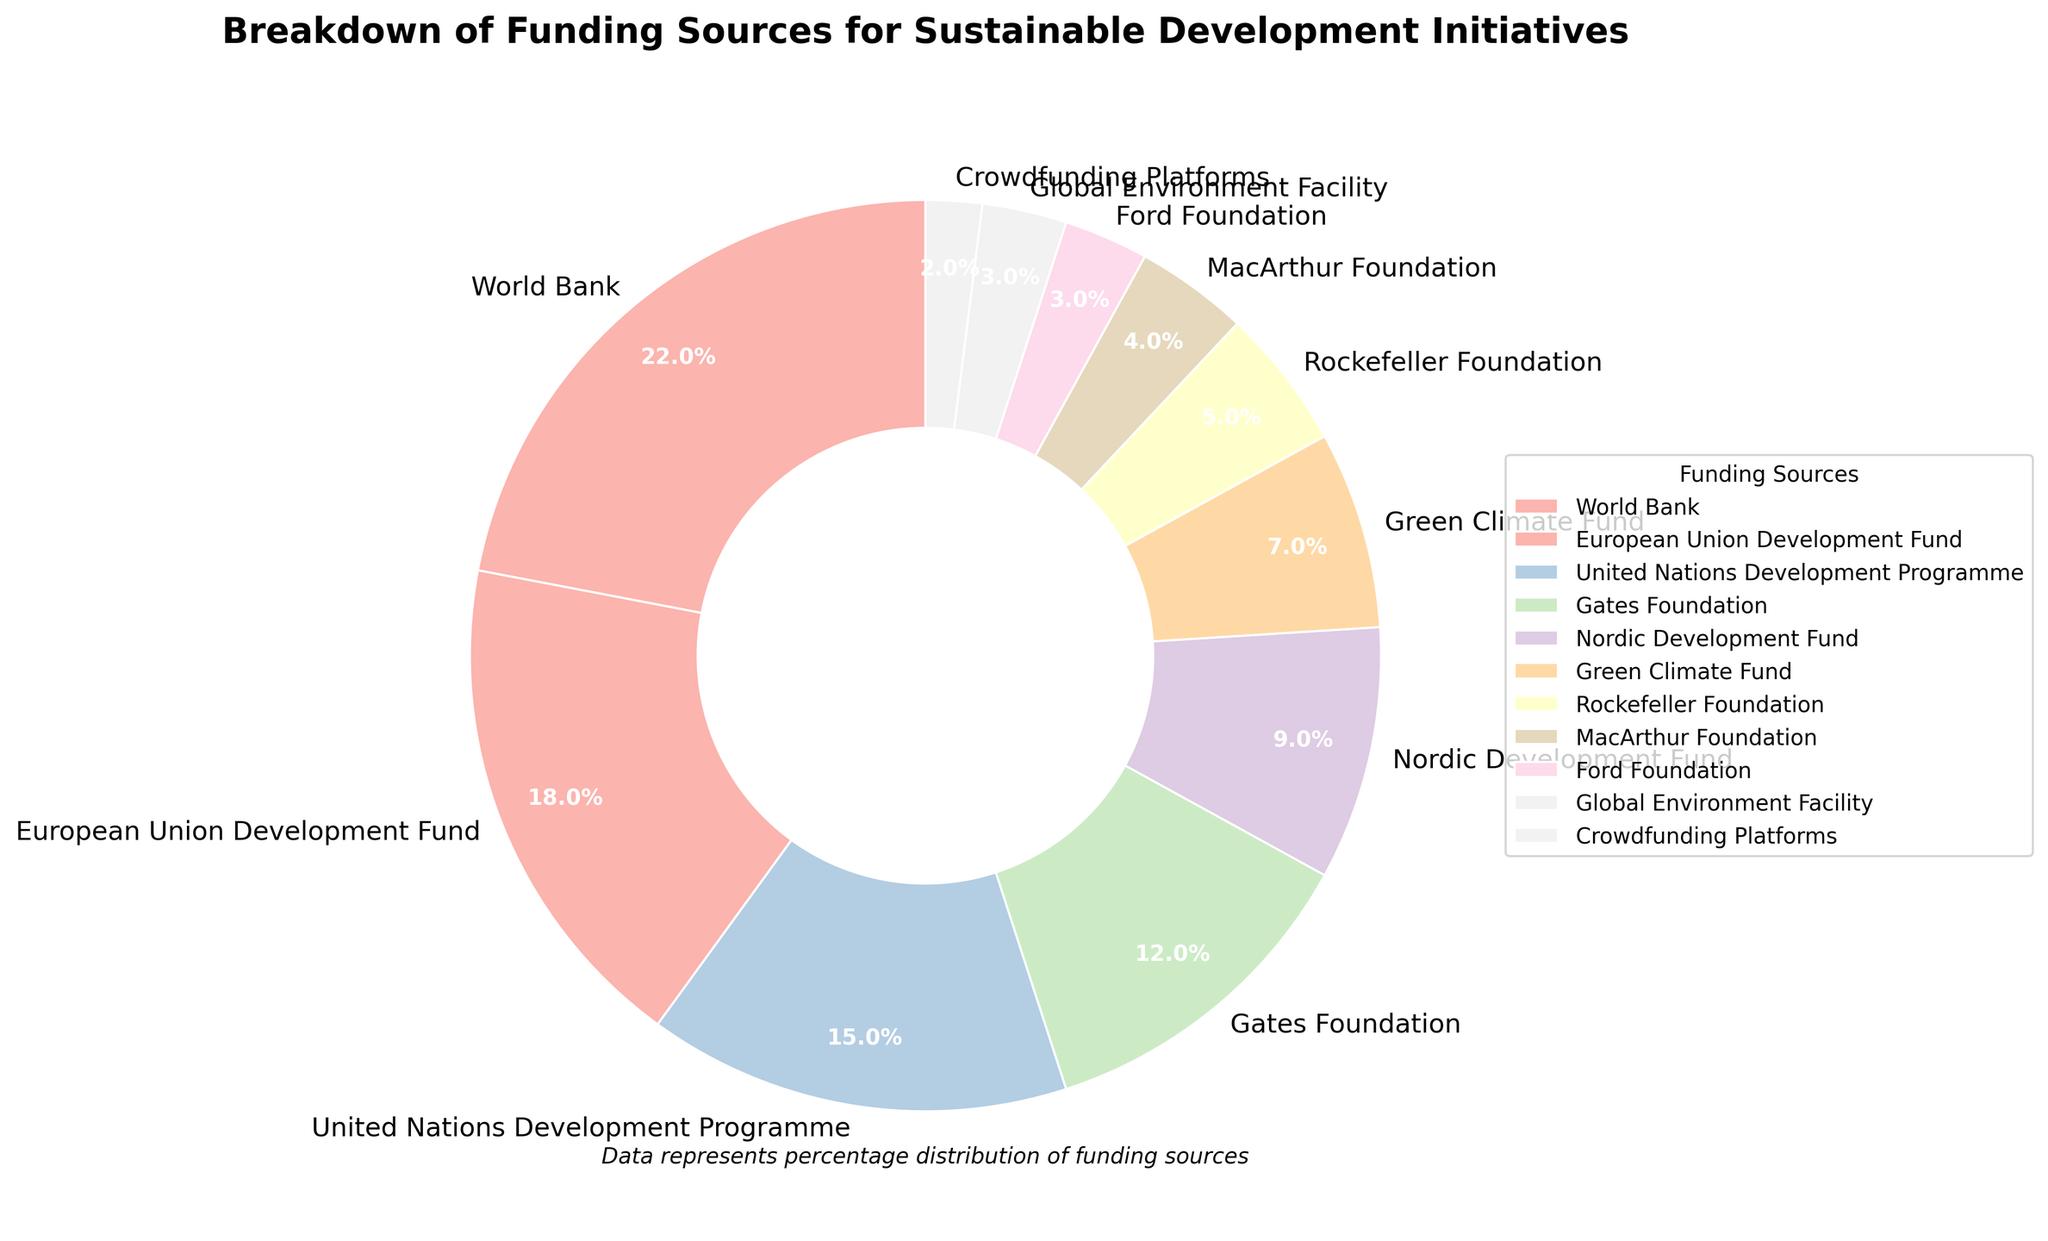What is the largest funding source and what percentage of total funding does it represent? The pie chart shows that the World Bank is the largest funding source with a 22% share of the total funding.
Answer: World Bank, 22% Which funding source has the second-highest percentage? The chart indicates that the European Union Development Fund holds the second-highest funding share at 18%.
Answer: European Union Development Fund, 18% How much more funding percentage does the World Bank provide compared to the Gates Foundation? The World Bank provides 22% while the Gates Foundation provides 12%. The difference can be calculated as 22% - 12% = 10%.
Answer: 10% Which three sources together account for more than half of the total funding? The top three sources are the World Bank (22%), the European Union Development Fund (18%), and the United Nations Development Programme (15%). Summing these, 22% + 18% + 15% = 55%, which is more than half of the total funding.
Answer: World Bank, European Union Development Fund, United Nations Development Programme What is the combined funding percentage from Rockefeller Foundation, MacArthur Foundation, and Ford Foundation? The Rockefeller Foundation provides 5%, MacArthur Foundation 4%, and Ford Foundation 3%. Summing these, 5% + 4% + 3% = 12%.
Answer: 12% Is the Green Climate Fund's contribution greater than that of the MacArthur Foundation? The chart shows the Green Climate Fund at 7% and the MacArthur Foundation at 4%. Thus, the Green Climate Fund's contribution is greater.
Answer: Yes How many funding sources have a percentage less than 5%? Based on the chart, there are five sources with less than 5%: Rockefeller Foundation (5%), MacArthur Foundation (4%), Ford Foundation (3%), Global Environment Facility (3%), and Crowdfunding Platforms (2%).
Answer: 5 Which funding source has the smallest percentage, and what is it? The Crowdfunding Platforms have the smallest funding percentage at 2%.
Answer: Crowdfunding Platforms, 2% If you combine the percentages of the Nordic Development Fund and the Green Climate Fund, how much is their total contribution? The Nordic Development Fund contributes 9% and the Green Climate Fund 7%. Together, their total contribution is 9% + 7% = 16%.
Answer: 16% Is the combined funding from the United Nations Development Programme and the Gates Foundation greater than that from the European Union Development Fund? UNDP provides 15% and Gates Foundation 12%, combining to 27%. The European Union Development Fund provides 18%. Since 27% is greater than 18%, the combined funding from UNDP and Gates Foundation is indeed greater.
Answer: Yes 